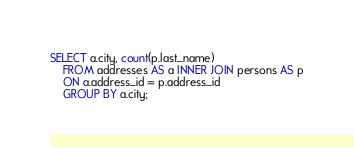<code> <loc_0><loc_0><loc_500><loc_500><_SQL_>SELECT a.city, count(p.last_name)
    FROM addresses AS a INNER JOIN persons AS p
    ON a.address_id = p.address_id
    GROUP BY a.city;
</code> 